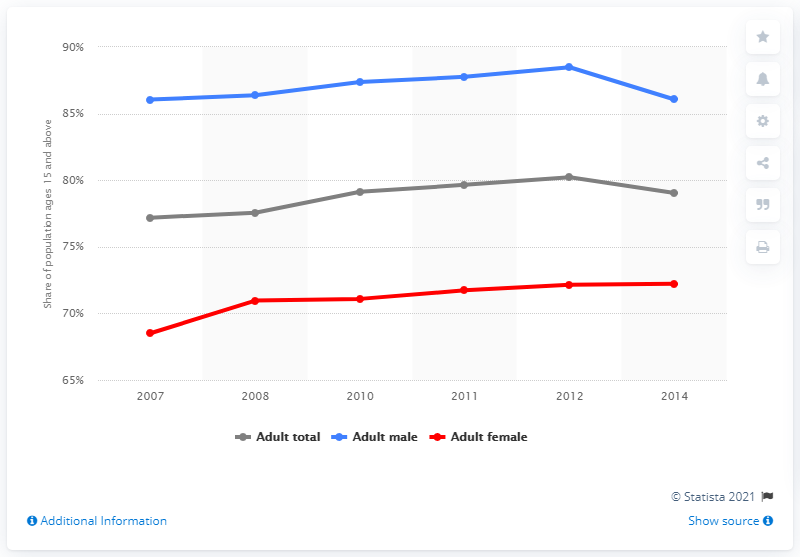Give some essential details in this illustration. In 2014, Tunisia's literacy rate was 79.04%. 